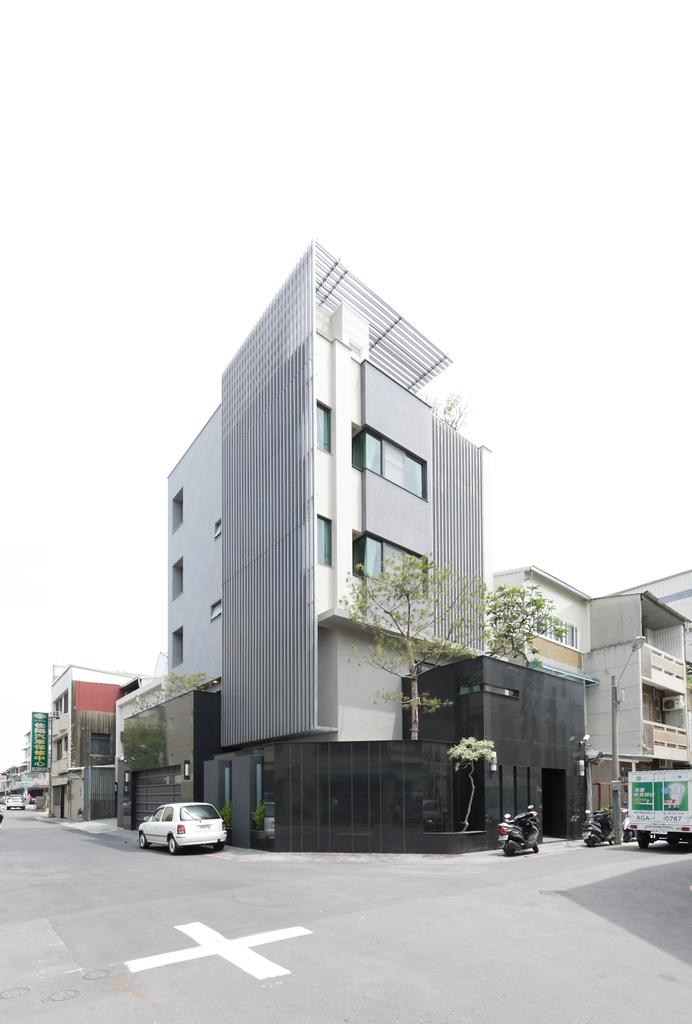What can be seen on the road in the image? There are vehicles on the road in the image. What type of structures are visible in the image? There are buildings visible in the image. What type of vegetation is present in the image? There are trees in the image. What is visible in the background of the image? The sky is visible in the background of the image. How many bells can be seen hanging from the trees in the image? There are no bells present in the image; it features vehicles on the road, buildings, trees, and the sky. Can you describe the girl and babies in the image? There is no girl or babies present in the image. 